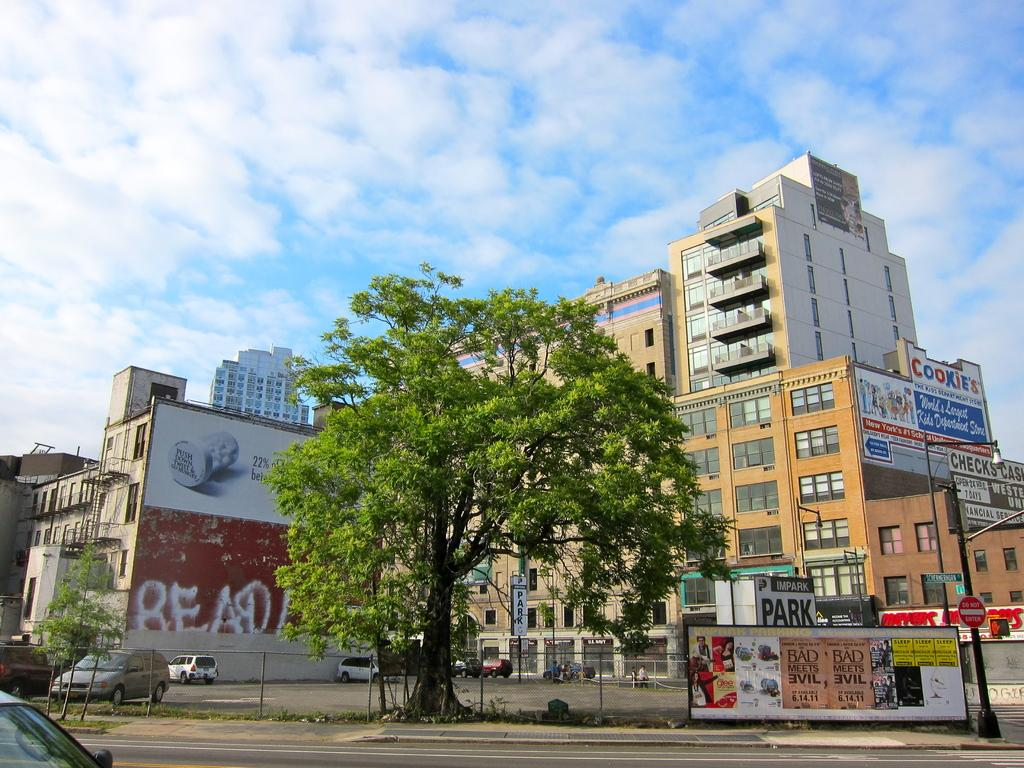What type of structures can be seen in the image? There are many buildings in the image. What type of lighting is present in the image? A street light is present in the image. What type of vegetation is visible in the image? A tree is visible in the image. How would you describe the sky in the image? The sky is slightly cloudy and blue. What type of vehicles can be seen in the image? There are parked cars in the parking zones. What type of apparel is being worn by the end of the street in the image? There is no apparel or people present in the image to determine what they might be wearing. What type of roll can be seen in the image? There is no roll present in the image. 